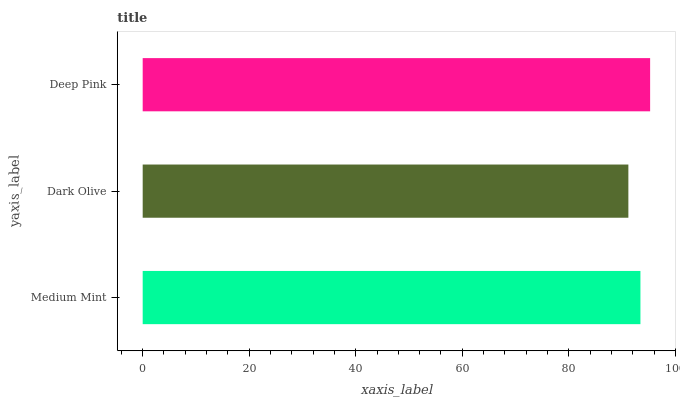Is Dark Olive the minimum?
Answer yes or no. Yes. Is Deep Pink the maximum?
Answer yes or no. Yes. Is Deep Pink the minimum?
Answer yes or no. No. Is Dark Olive the maximum?
Answer yes or no. No. Is Deep Pink greater than Dark Olive?
Answer yes or no. Yes. Is Dark Olive less than Deep Pink?
Answer yes or no. Yes. Is Dark Olive greater than Deep Pink?
Answer yes or no. No. Is Deep Pink less than Dark Olive?
Answer yes or no. No. Is Medium Mint the high median?
Answer yes or no. Yes. Is Medium Mint the low median?
Answer yes or no. Yes. Is Deep Pink the high median?
Answer yes or no. No. Is Deep Pink the low median?
Answer yes or no. No. 